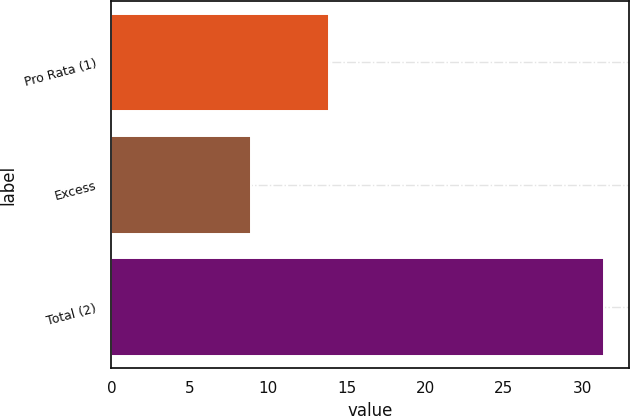Convert chart to OTSL. <chart><loc_0><loc_0><loc_500><loc_500><bar_chart><fcel>Pro Rata (1)<fcel>Excess<fcel>Total (2)<nl><fcel>13.9<fcel>8.9<fcel>31.4<nl></chart> 